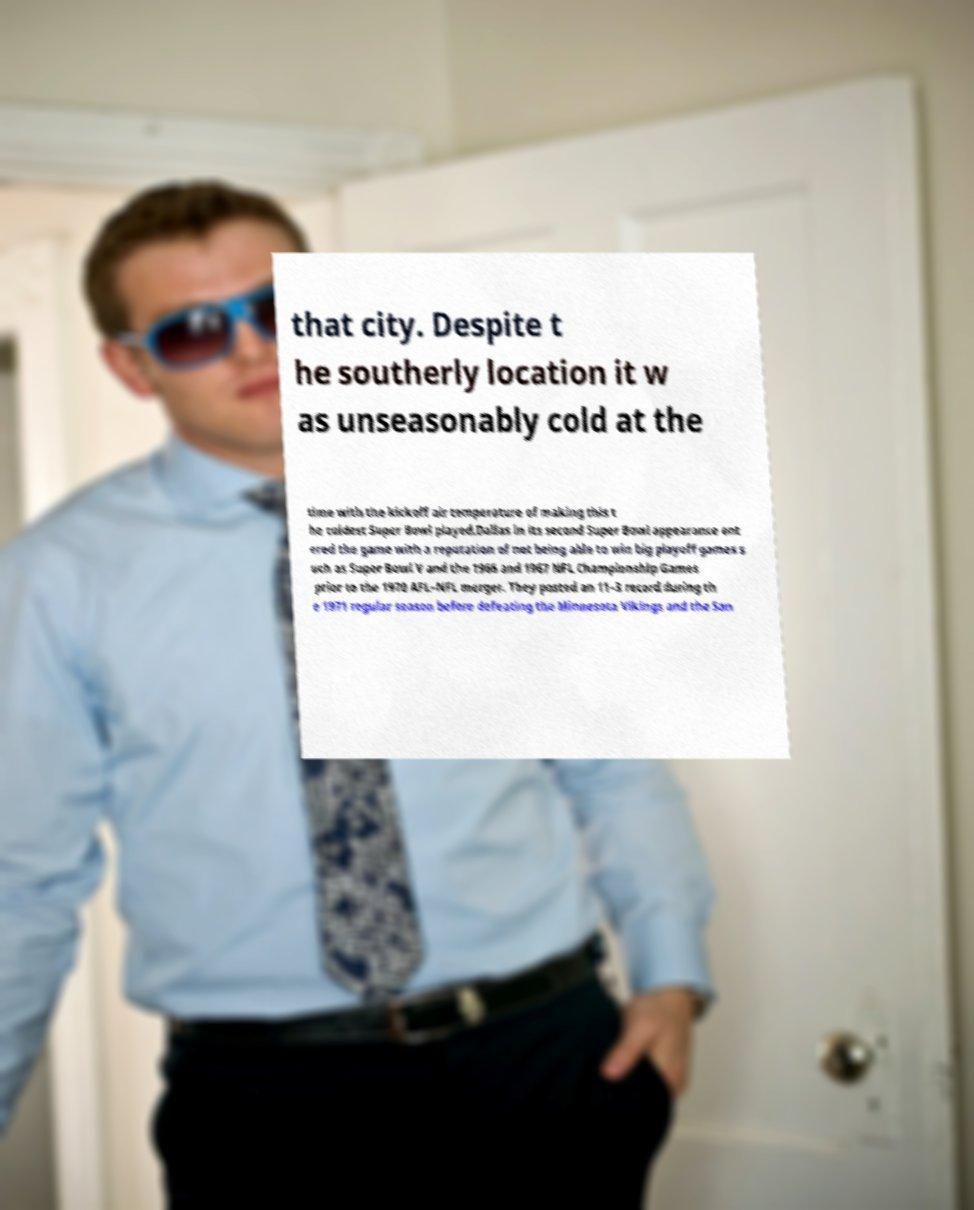Please identify and transcribe the text found in this image. that city. Despite t he southerly location it w as unseasonably cold at the time with the kickoff air temperature of making this t he coldest Super Bowl played.Dallas in its second Super Bowl appearance ent ered the game with a reputation of not being able to win big playoff games s uch as Super Bowl V and the 1966 and 1967 NFL Championship Games prior to the 1970 AFL–NFL merger. They posted an 11–3 record during th e 1971 regular season before defeating the Minnesota Vikings and the San 